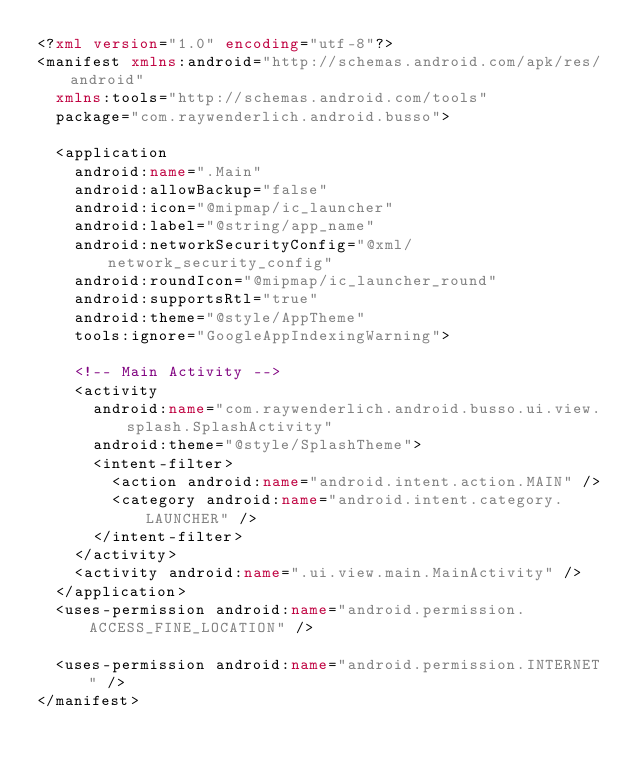<code> <loc_0><loc_0><loc_500><loc_500><_XML_><?xml version="1.0" encoding="utf-8"?>
<manifest xmlns:android="http://schemas.android.com/apk/res/android"
  xmlns:tools="http://schemas.android.com/tools"
  package="com.raywenderlich.android.busso">

  <application
    android:name=".Main"
    android:allowBackup="false"
    android:icon="@mipmap/ic_launcher"
    android:label="@string/app_name"
    android:networkSecurityConfig="@xml/network_security_config"
    android:roundIcon="@mipmap/ic_launcher_round"
    android:supportsRtl="true"
    android:theme="@style/AppTheme"
    tools:ignore="GoogleAppIndexingWarning">

    <!-- Main Activity -->
    <activity
      android:name="com.raywenderlich.android.busso.ui.view.splash.SplashActivity"
      android:theme="@style/SplashTheme">
      <intent-filter>
        <action android:name="android.intent.action.MAIN" />
        <category android:name="android.intent.category.LAUNCHER" />
      </intent-filter>
    </activity>
    <activity android:name=".ui.view.main.MainActivity" />
  </application>
  <uses-permission android:name="android.permission.ACCESS_FINE_LOCATION" />

  <uses-permission android:name="android.permission.INTERNET" />
</manifest>
</code> 